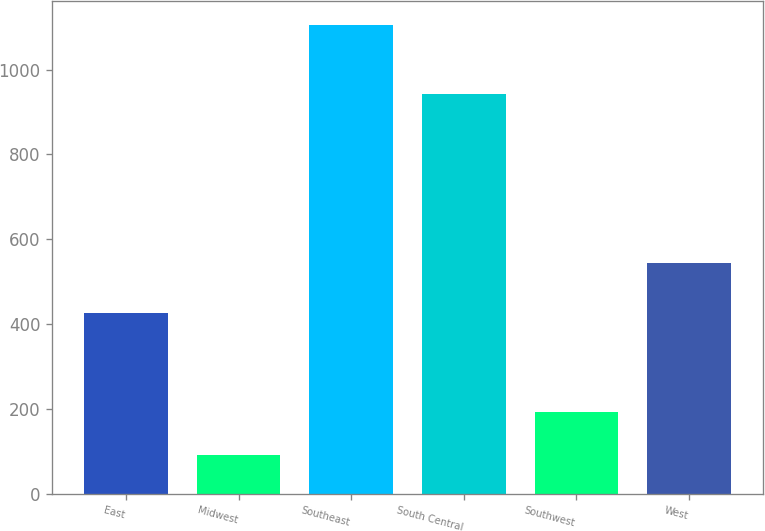<chart> <loc_0><loc_0><loc_500><loc_500><bar_chart><fcel>East<fcel>Midwest<fcel>Southeast<fcel>South Central<fcel>Southwest<fcel>West<nl><fcel>425.4<fcel>91.6<fcel>1105.9<fcel>942.5<fcel>193.03<fcel>544.7<nl></chart> 